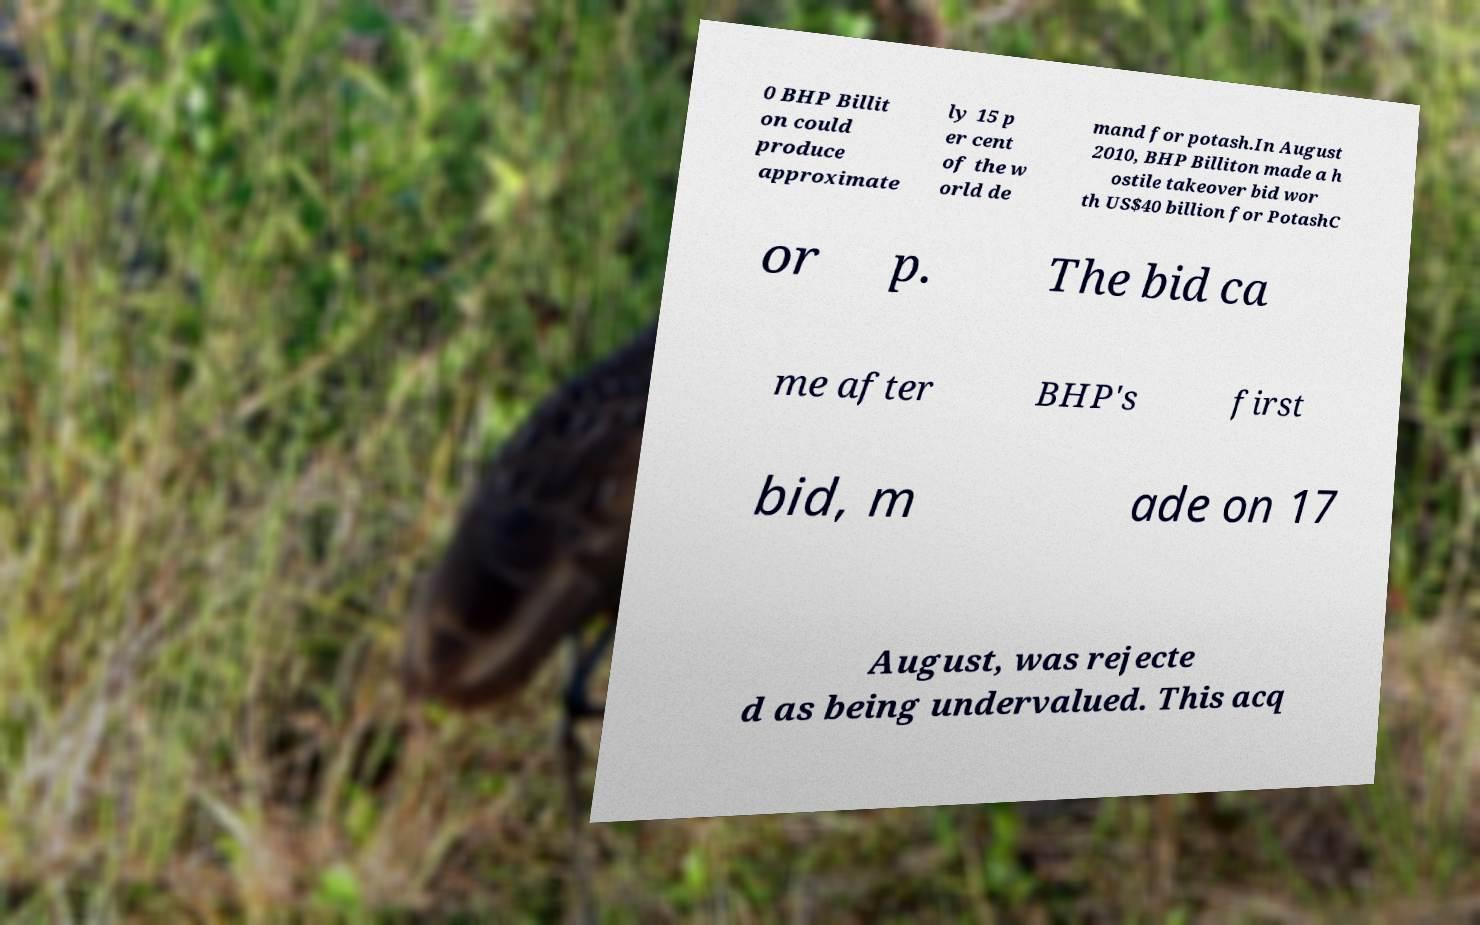I need the written content from this picture converted into text. Can you do that? 0 BHP Billit on could produce approximate ly 15 p er cent of the w orld de mand for potash.In August 2010, BHP Billiton made a h ostile takeover bid wor th US$40 billion for PotashC or p. The bid ca me after BHP's first bid, m ade on 17 August, was rejecte d as being undervalued. This acq 